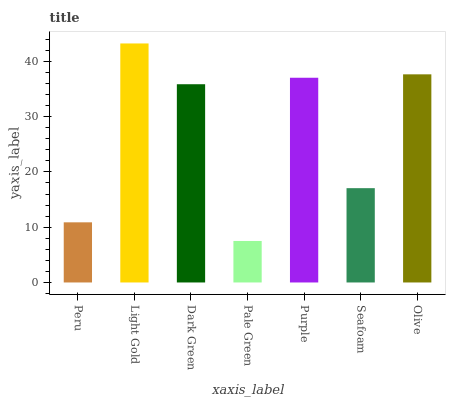Is Pale Green the minimum?
Answer yes or no. Yes. Is Light Gold the maximum?
Answer yes or no. Yes. Is Dark Green the minimum?
Answer yes or no. No. Is Dark Green the maximum?
Answer yes or no. No. Is Light Gold greater than Dark Green?
Answer yes or no. Yes. Is Dark Green less than Light Gold?
Answer yes or no. Yes. Is Dark Green greater than Light Gold?
Answer yes or no. No. Is Light Gold less than Dark Green?
Answer yes or no. No. Is Dark Green the high median?
Answer yes or no. Yes. Is Dark Green the low median?
Answer yes or no. Yes. Is Pale Green the high median?
Answer yes or no. No. Is Pale Green the low median?
Answer yes or no. No. 